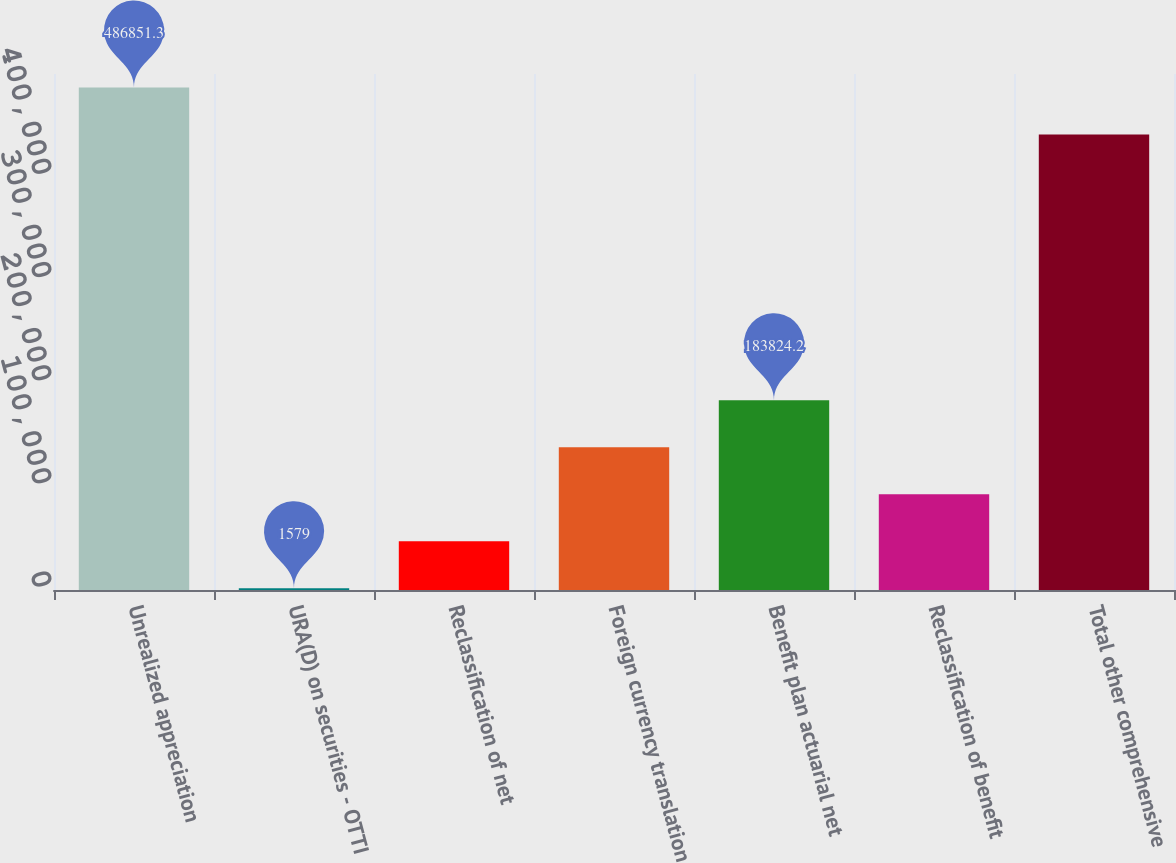<chart> <loc_0><loc_0><loc_500><loc_500><bar_chart><fcel>Unrealized appreciation<fcel>URA(D) on securities - OTTI<fcel>Reclassification of net<fcel>Foreign currency translation<fcel>Benefit plan actuarial net<fcel>Reclassification of benefit<fcel>Total other comprehensive<nl><fcel>486851<fcel>1579<fcel>47140.3<fcel>138263<fcel>183824<fcel>92701.6<fcel>441290<nl></chart> 